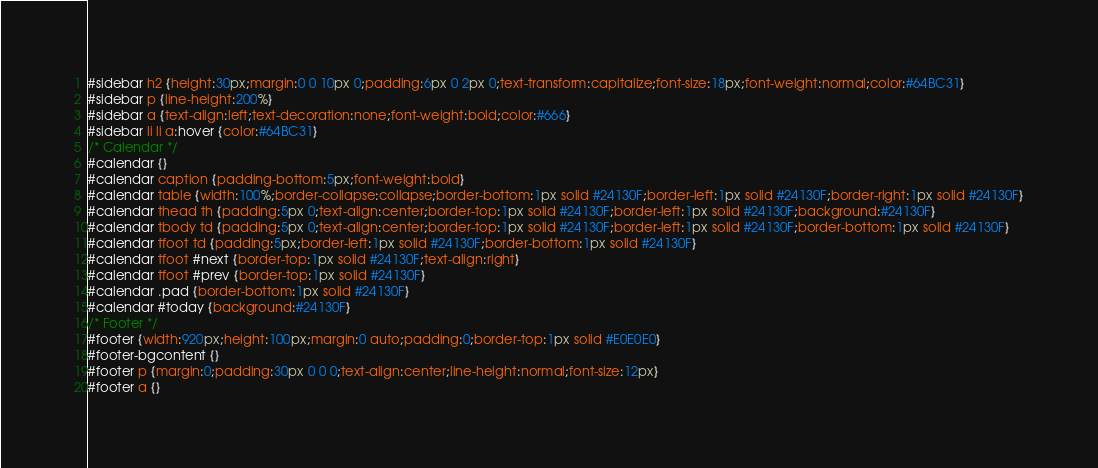Convert code to text. <code><loc_0><loc_0><loc_500><loc_500><_CSS_>#sidebar h2 {height:30px;margin:0 0 10px 0;padding:6px 0 2px 0;text-transform:capitalize;font-size:18px;font-weight:normal;color:#64BC31}
#sidebar p {line-height:200%}
#sidebar a {text-align:left;text-decoration:none;font-weight:bold;color:#666}
#sidebar li li a:hover {color:#64BC31}
/* Calendar */
#calendar {}
#calendar caption {padding-bottom:5px;font-weight:bold}
#calendar table {width:100%;border-collapse:collapse;border-bottom:1px solid #24130F;border-left:1px solid #24130F;border-right:1px solid #24130F}
#calendar thead th {padding:5px 0;text-align:center;border-top:1px solid #24130F;border-left:1px solid #24130F;background:#24130F}
#calendar tbody td {padding:5px 0;text-align:center;border-top:1px solid #24130F;border-left:1px solid #24130F;border-bottom:1px solid #24130F}
#calendar tfoot td {padding:5px;border-left:1px solid #24130F;border-bottom:1px solid #24130F}
#calendar tfoot #next {border-top:1px solid #24130F;text-align:right}
#calendar tfoot #prev {border-top:1px solid #24130F}
#calendar .pad {border-bottom:1px solid #24130F}
#calendar #today {background:#24130F}
/* Footer */
#footer {width:920px;height:100px;margin:0 auto;padding:0;border-top:1px solid #E0E0E0}
#footer-bgcontent {}
#footer p {margin:0;padding:30px 0 0 0;text-align:center;line-height:normal;font-size:12px}
#footer a {}</code> 